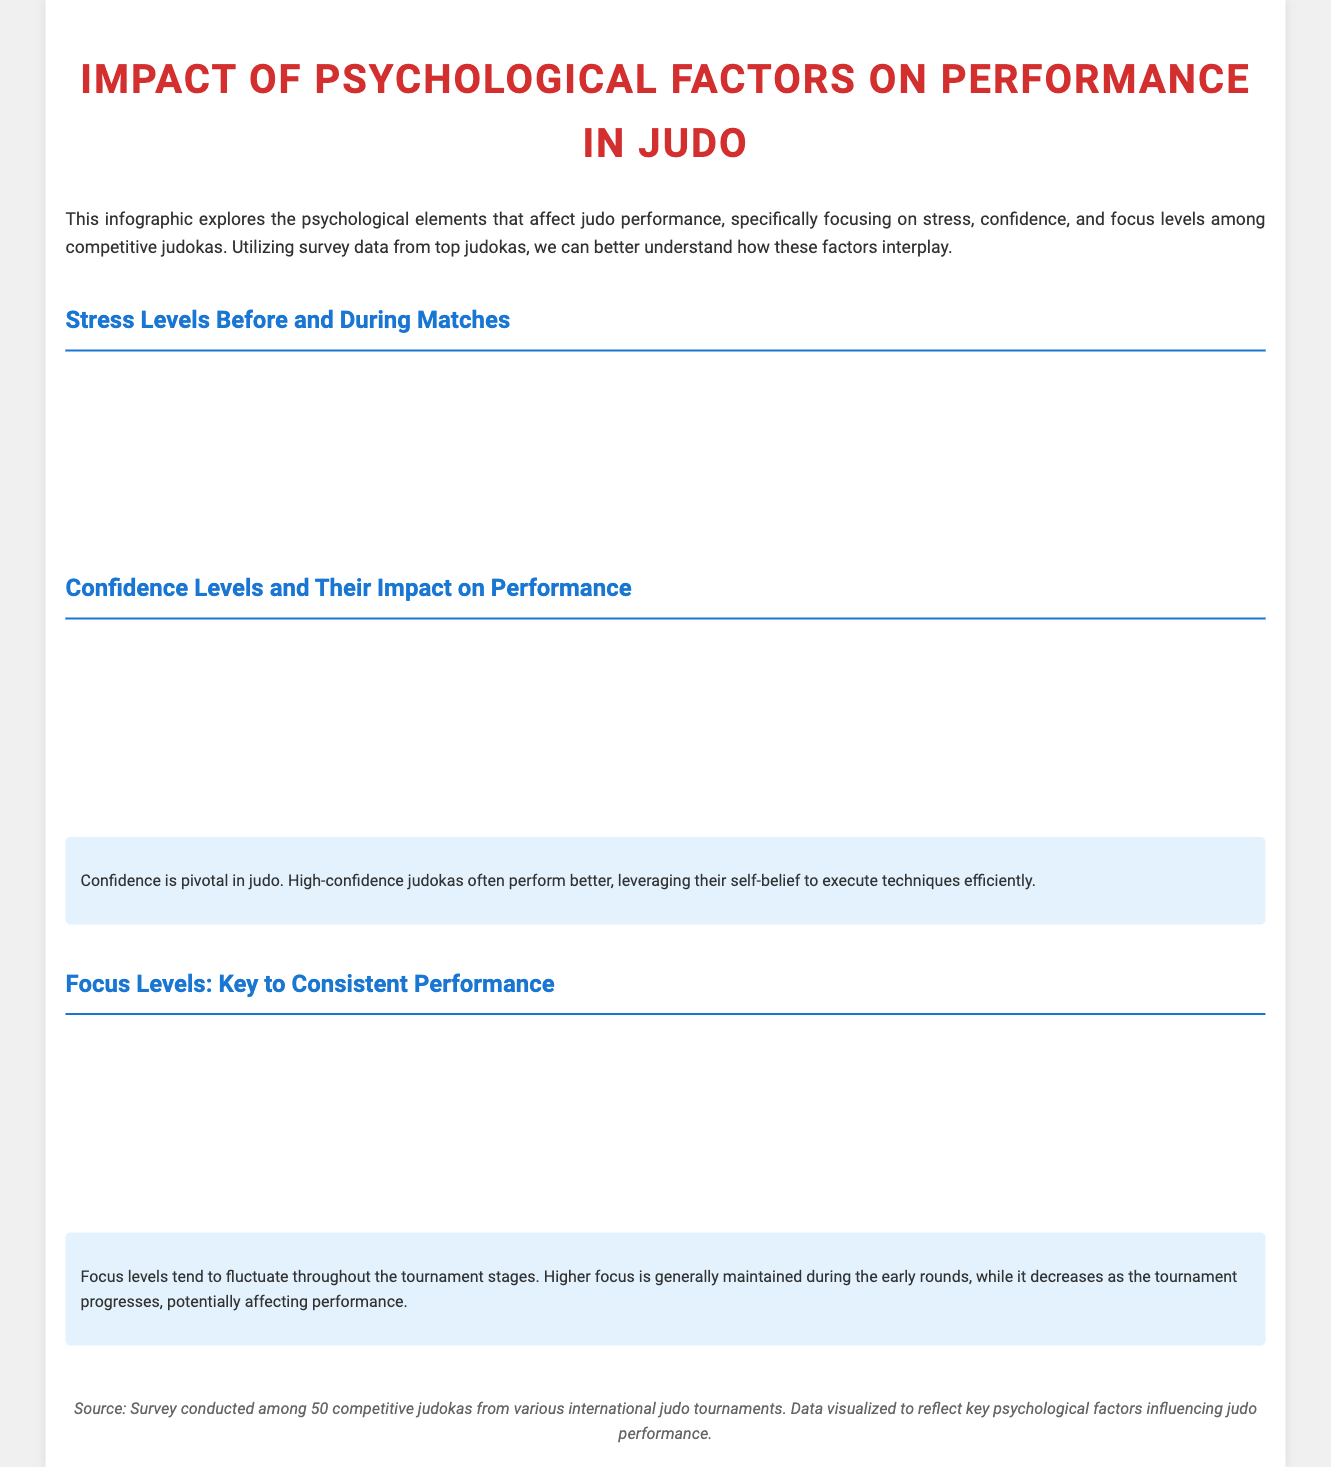What is the title of the infographic? The title is prominently displayed at the top of the document, indicating the main topic of focus.
Answer: Impact of Psychological Factors on Performance in Judo What percentage of judokas reported high confidence? This information is available in the confidence levels pie chart, revealing insights into the distribution of confidence among the surveyed judokas.
Answer: 40 What were the stress levels during matches for high stress? The data reflects the stress levels before and during matches, showing a significant increase during matches for high stress.
Answer: 80 Which stage had the highest focus level? By analyzing the focus levels line chart, the stage with the highest measurement can be determined.
Answer: First Round What do high-confidence judokas tend to do? The description below the confidence levels chart outlines the behavior and advantages of judokas with high confidence.
Answer: Perform better How many total competitive judokas participated in the survey? The source section of the document mentions the number of judokas surveyed, providing context for the data presented.
Answer: 50 What type of chart is used to display stress levels? The chart used can be identified by its style and type mentioned in the section headings.
Answer: Bar What is the main psychological factor discussed in the infographic? A quick overview or introduction to the document reveals the main focus of the study and the surveyed factors.
Answer: Psychological factors 